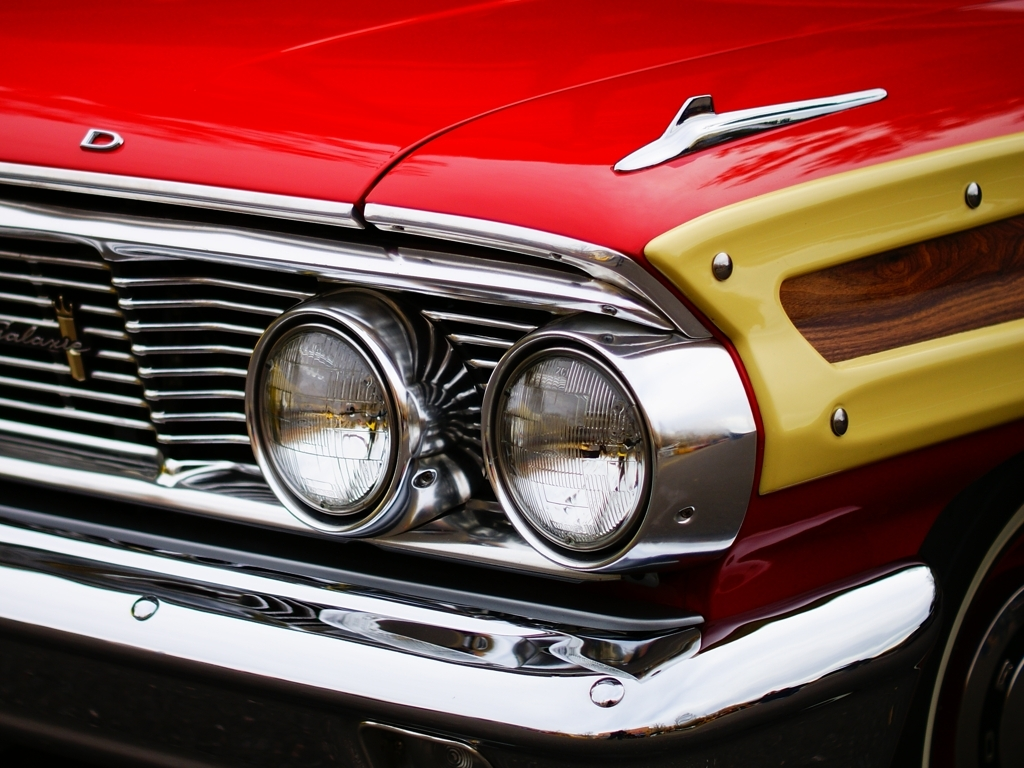What era does the car's design suggest? The design of this car, with its sweeping lines, two-tone paint, and prominent front grille with chrome detailing, suggests that it's a classic from the 1950s or 1960s—a period known for iconic car designs that exuded style and elegance. 